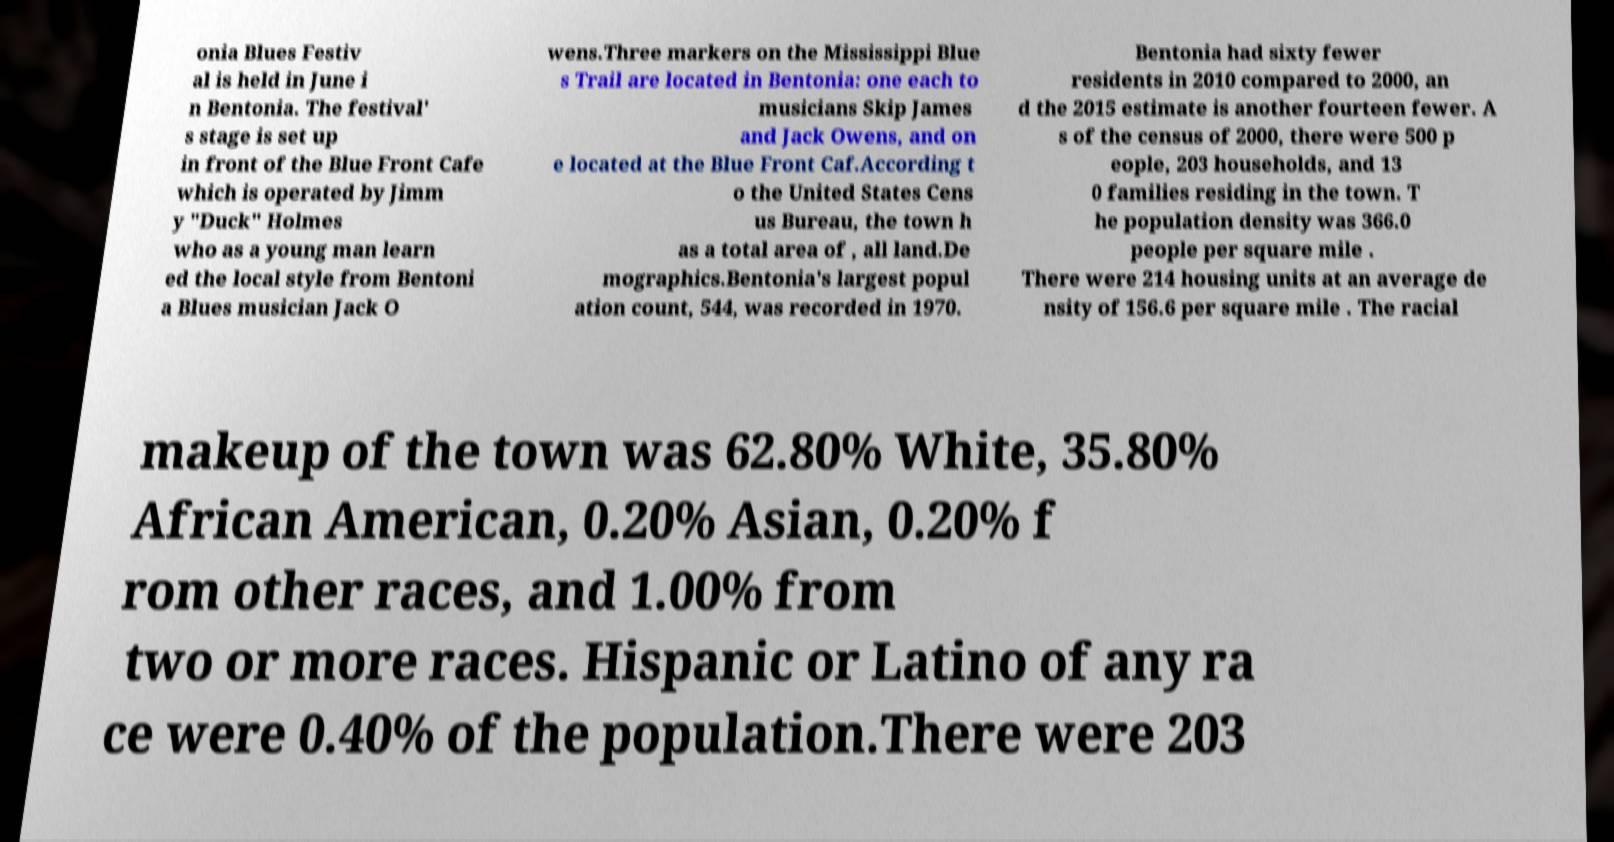Could you assist in decoding the text presented in this image and type it out clearly? onia Blues Festiv al is held in June i n Bentonia. The festival' s stage is set up in front of the Blue Front Cafe which is operated by Jimm y "Duck" Holmes who as a young man learn ed the local style from Bentoni a Blues musician Jack O wens.Three markers on the Mississippi Blue s Trail are located in Bentonia: one each to musicians Skip James and Jack Owens, and on e located at the Blue Front Caf.According t o the United States Cens us Bureau, the town h as a total area of , all land.De mographics.Bentonia's largest popul ation count, 544, was recorded in 1970. Bentonia had sixty fewer residents in 2010 compared to 2000, an d the 2015 estimate is another fourteen fewer. A s of the census of 2000, there were 500 p eople, 203 households, and 13 0 families residing in the town. T he population density was 366.0 people per square mile . There were 214 housing units at an average de nsity of 156.6 per square mile . The racial makeup of the town was 62.80% White, 35.80% African American, 0.20% Asian, 0.20% f rom other races, and 1.00% from two or more races. Hispanic or Latino of any ra ce were 0.40% of the population.There were 203 